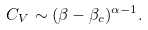Convert formula to latex. <formula><loc_0><loc_0><loc_500><loc_500>C _ { V } \sim ( \beta - \beta _ { c } ) ^ { \alpha - 1 } .</formula> 